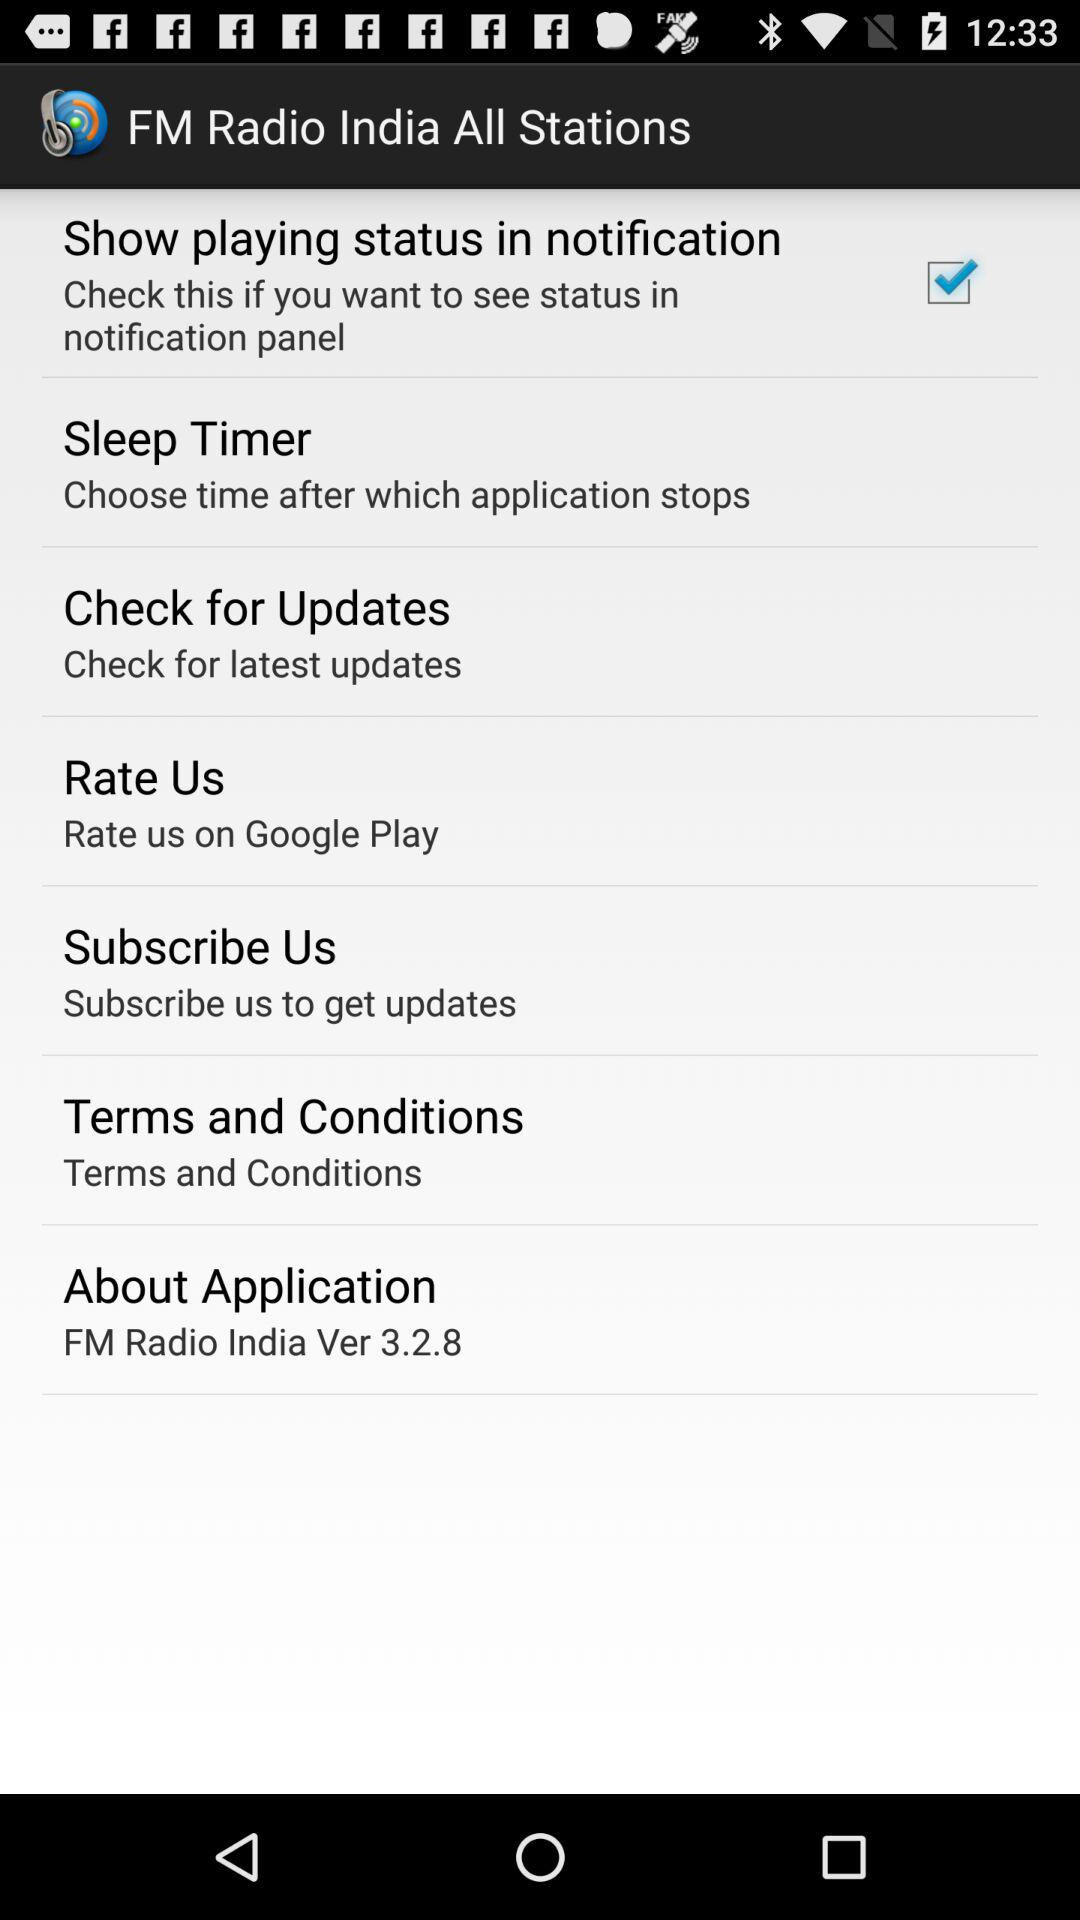What is the application name? The application name is "FM Radio India All Stations". 